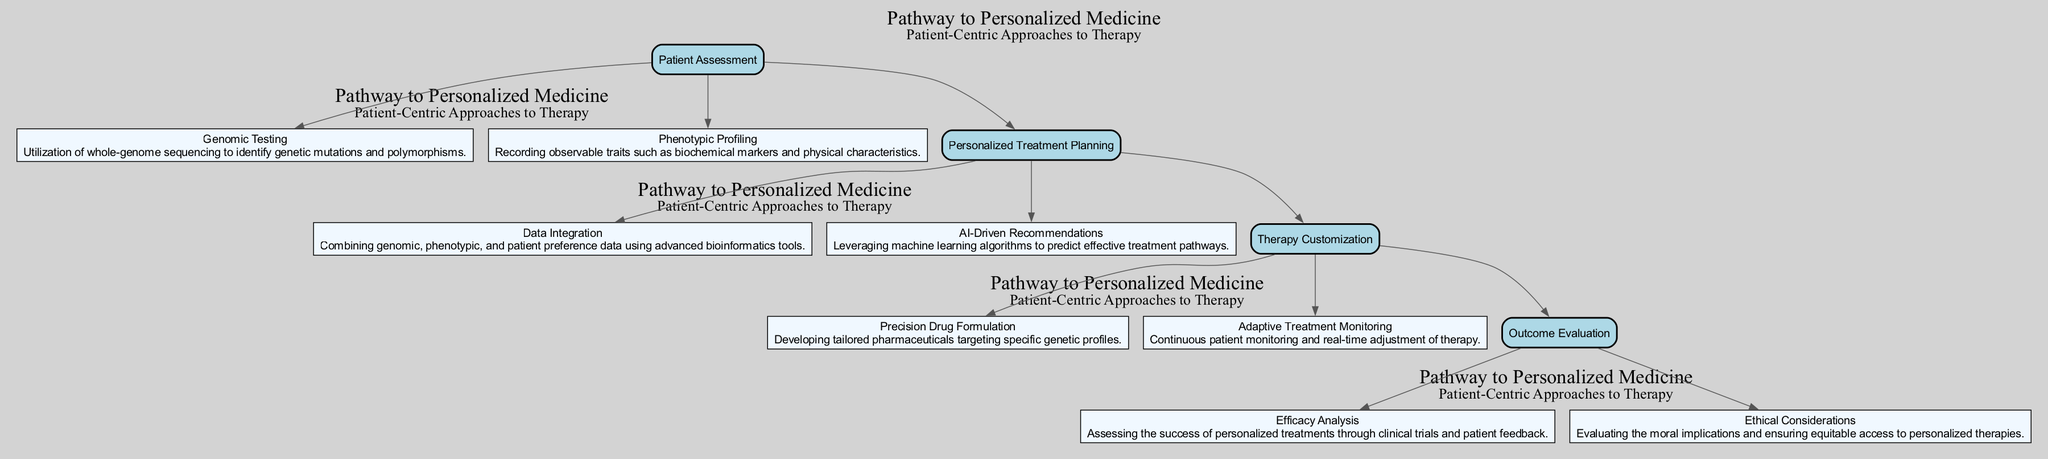What is the title of the pathway? The title is located at the top of the diagram as indicated in the introduction section. It directly conveys the main subject of the clinical pathway.
Answer: Pathway to Personalized Medicine How many key steps are there in the diagram? By counting the steps listed under the "KeySteps" section, we observe that there are four distinct steps represented in the pathway.
Answer: 4 What is the first component in "Patient Assessment"? The first component is listed in the detailed breakdown under "Patient Assessment," indicating the first element to be addressed in this step.
Answer: Genomic Testing What does "AI-Driven Recommendations" pertain to? "AI-Driven Recommendations" is associated with the "Personalized Treatment Planning" step, indicating its role in suggesting treatment pathways based on data analysis.
Answer: Personalized Treatment Planning How is therapy monitored according to the diagram? The diagram describes continuous monitoring and adjustment of therapy under the component "Adaptive Treatment Monitoring" in the "Therapy Customization" step.
Answer: Adaptive Treatment Monitoring What assessment method follows "Therapy Customization"? The diagram clearly shows that after "Therapy Customization," the next step is "Outcome Evaluation," indicating the flow of actions in personalized medicine.
Answer: Outcome Evaluation What are the ethical implications mentioned in the pathway? The aspect of ethical implications is described under the "Outcome Evaluation" step, suggesting a focus on moral considerations regarding personalized therapies.
Answer: Ethical Considerations What type of analysis evaluates treatment success? The analysis method indicated in the "Outcome Evaluation" step that pertains to assessing treatment success is the "Efficacy Analysis," which combines clinical trial and feedback data.
Answer: Efficacy Analysis Which two components help in personalized treatment planning? The pathway lists "Data Integration" and "AI-Driven Recommendations" as components helping in crafting personalized treatment approaches, reflecting a dual focus on data and technology.
Answer: Data Integration, AI-Driven Recommendations 